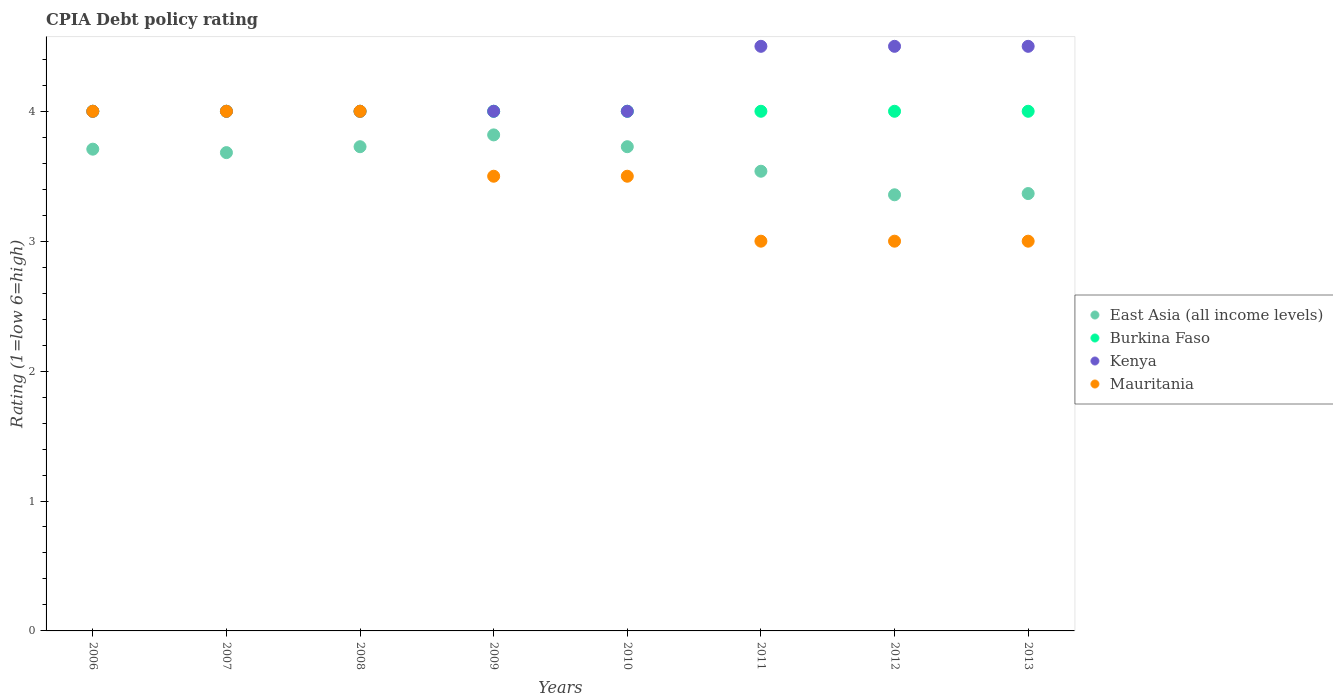How many different coloured dotlines are there?
Your answer should be compact. 4. What is the CPIA rating in East Asia (all income levels) in 2008?
Give a very brief answer. 3.73. Across all years, what is the maximum CPIA rating in East Asia (all income levels)?
Give a very brief answer. 3.82. Across all years, what is the minimum CPIA rating in East Asia (all income levels)?
Provide a succinct answer. 3.36. What is the total CPIA rating in Kenya in the graph?
Your response must be concise. 33.5. What is the difference between the CPIA rating in Burkina Faso in 2008 and the CPIA rating in Kenya in 2012?
Your answer should be very brief. -0.5. What is the average CPIA rating in Mauritania per year?
Your answer should be very brief. 3.5. In the year 2007, what is the difference between the CPIA rating in East Asia (all income levels) and CPIA rating in Kenya?
Your answer should be compact. -0.32. In how many years, is the CPIA rating in Mauritania greater than 3?
Ensure brevity in your answer.  5. What is the ratio of the CPIA rating in Kenya in 2009 to that in 2012?
Offer a terse response. 0.89. Is the CPIA rating in Burkina Faso in 2009 less than that in 2010?
Your answer should be very brief. No. Is the difference between the CPIA rating in East Asia (all income levels) in 2008 and 2009 greater than the difference between the CPIA rating in Kenya in 2008 and 2009?
Keep it short and to the point. No. What is the difference between the highest and the second highest CPIA rating in Burkina Faso?
Your response must be concise. 0. What is the difference between the highest and the lowest CPIA rating in Burkina Faso?
Provide a short and direct response. 0. Is the sum of the CPIA rating in Burkina Faso in 2008 and 2010 greater than the maximum CPIA rating in Mauritania across all years?
Provide a succinct answer. Yes. Is it the case that in every year, the sum of the CPIA rating in Mauritania and CPIA rating in Burkina Faso  is greater than the sum of CPIA rating in Kenya and CPIA rating in East Asia (all income levels)?
Offer a terse response. No. Is it the case that in every year, the sum of the CPIA rating in Burkina Faso and CPIA rating in Mauritania  is greater than the CPIA rating in Kenya?
Your response must be concise. Yes. Is the CPIA rating in Burkina Faso strictly greater than the CPIA rating in Kenya over the years?
Offer a very short reply. No. How many years are there in the graph?
Keep it short and to the point. 8. What is the difference between two consecutive major ticks on the Y-axis?
Make the answer very short. 1. Does the graph contain any zero values?
Keep it short and to the point. No. Does the graph contain grids?
Offer a terse response. No. What is the title of the graph?
Provide a succinct answer. CPIA Debt policy rating. Does "Guyana" appear as one of the legend labels in the graph?
Your response must be concise. No. What is the label or title of the Y-axis?
Offer a very short reply. Rating (1=low 6=high). What is the Rating (1=low 6=high) of East Asia (all income levels) in 2006?
Provide a short and direct response. 3.71. What is the Rating (1=low 6=high) in Mauritania in 2006?
Keep it short and to the point. 4. What is the Rating (1=low 6=high) in East Asia (all income levels) in 2007?
Keep it short and to the point. 3.68. What is the Rating (1=low 6=high) of Mauritania in 2007?
Provide a short and direct response. 4. What is the Rating (1=low 6=high) in East Asia (all income levels) in 2008?
Provide a short and direct response. 3.73. What is the Rating (1=low 6=high) of Burkina Faso in 2008?
Your answer should be compact. 4. What is the Rating (1=low 6=high) in East Asia (all income levels) in 2009?
Your answer should be very brief. 3.82. What is the Rating (1=low 6=high) of Burkina Faso in 2009?
Provide a short and direct response. 4. What is the Rating (1=low 6=high) of Kenya in 2009?
Keep it short and to the point. 4. What is the Rating (1=low 6=high) in East Asia (all income levels) in 2010?
Your answer should be compact. 3.73. What is the Rating (1=low 6=high) in Kenya in 2010?
Your answer should be compact. 4. What is the Rating (1=low 6=high) in East Asia (all income levels) in 2011?
Make the answer very short. 3.54. What is the Rating (1=low 6=high) in Burkina Faso in 2011?
Ensure brevity in your answer.  4. What is the Rating (1=low 6=high) of Kenya in 2011?
Your response must be concise. 4.5. What is the Rating (1=low 6=high) in Mauritania in 2011?
Keep it short and to the point. 3. What is the Rating (1=low 6=high) of East Asia (all income levels) in 2012?
Your answer should be compact. 3.36. What is the Rating (1=low 6=high) of Kenya in 2012?
Your answer should be very brief. 4.5. What is the Rating (1=low 6=high) in Mauritania in 2012?
Your answer should be very brief. 3. What is the Rating (1=low 6=high) of East Asia (all income levels) in 2013?
Offer a terse response. 3.37. What is the Rating (1=low 6=high) of Burkina Faso in 2013?
Your answer should be compact. 4. What is the Rating (1=low 6=high) in Mauritania in 2013?
Keep it short and to the point. 3. Across all years, what is the maximum Rating (1=low 6=high) of East Asia (all income levels)?
Your response must be concise. 3.82. Across all years, what is the maximum Rating (1=low 6=high) in Burkina Faso?
Your answer should be very brief. 4. Across all years, what is the maximum Rating (1=low 6=high) of Kenya?
Your answer should be very brief. 4.5. Across all years, what is the maximum Rating (1=low 6=high) in Mauritania?
Offer a very short reply. 4. Across all years, what is the minimum Rating (1=low 6=high) in East Asia (all income levels)?
Offer a terse response. 3.36. Across all years, what is the minimum Rating (1=low 6=high) in Burkina Faso?
Provide a short and direct response. 4. Across all years, what is the minimum Rating (1=low 6=high) of Mauritania?
Offer a very short reply. 3. What is the total Rating (1=low 6=high) in East Asia (all income levels) in the graph?
Provide a succinct answer. 28.93. What is the total Rating (1=low 6=high) in Burkina Faso in the graph?
Offer a very short reply. 32. What is the total Rating (1=low 6=high) of Kenya in the graph?
Your response must be concise. 33.5. What is the difference between the Rating (1=low 6=high) in East Asia (all income levels) in 2006 and that in 2007?
Offer a terse response. 0.03. What is the difference between the Rating (1=low 6=high) of Burkina Faso in 2006 and that in 2007?
Offer a terse response. 0. What is the difference between the Rating (1=low 6=high) of Kenya in 2006 and that in 2007?
Give a very brief answer. 0. What is the difference between the Rating (1=low 6=high) of East Asia (all income levels) in 2006 and that in 2008?
Offer a very short reply. -0.02. What is the difference between the Rating (1=low 6=high) in East Asia (all income levels) in 2006 and that in 2009?
Make the answer very short. -0.11. What is the difference between the Rating (1=low 6=high) of Burkina Faso in 2006 and that in 2009?
Your answer should be compact. 0. What is the difference between the Rating (1=low 6=high) in Kenya in 2006 and that in 2009?
Give a very brief answer. 0. What is the difference between the Rating (1=low 6=high) in Mauritania in 2006 and that in 2009?
Make the answer very short. 0.5. What is the difference between the Rating (1=low 6=high) in East Asia (all income levels) in 2006 and that in 2010?
Provide a succinct answer. -0.02. What is the difference between the Rating (1=low 6=high) in Burkina Faso in 2006 and that in 2010?
Your answer should be very brief. 0. What is the difference between the Rating (1=low 6=high) of Kenya in 2006 and that in 2010?
Provide a succinct answer. 0. What is the difference between the Rating (1=low 6=high) of Mauritania in 2006 and that in 2010?
Ensure brevity in your answer.  0.5. What is the difference between the Rating (1=low 6=high) of East Asia (all income levels) in 2006 and that in 2011?
Ensure brevity in your answer.  0.17. What is the difference between the Rating (1=low 6=high) in Mauritania in 2006 and that in 2011?
Keep it short and to the point. 1. What is the difference between the Rating (1=low 6=high) in East Asia (all income levels) in 2006 and that in 2012?
Provide a short and direct response. 0.35. What is the difference between the Rating (1=low 6=high) in Mauritania in 2006 and that in 2012?
Your answer should be very brief. 1. What is the difference between the Rating (1=low 6=high) of East Asia (all income levels) in 2006 and that in 2013?
Keep it short and to the point. 0.34. What is the difference between the Rating (1=low 6=high) in Burkina Faso in 2006 and that in 2013?
Make the answer very short. 0. What is the difference between the Rating (1=low 6=high) of East Asia (all income levels) in 2007 and that in 2008?
Make the answer very short. -0.05. What is the difference between the Rating (1=low 6=high) of Burkina Faso in 2007 and that in 2008?
Offer a very short reply. 0. What is the difference between the Rating (1=low 6=high) in East Asia (all income levels) in 2007 and that in 2009?
Your answer should be very brief. -0.14. What is the difference between the Rating (1=low 6=high) of East Asia (all income levels) in 2007 and that in 2010?
Provide a succinct answer. -0.05. What is the difference between the Rating (1=low 6=high) of Burkina Faso in 2007 and that in 2010?
Your answer should be compact. 0. What is the difference between the Rating (1=low 6=high) in East Asia (all income levels) in 2007 and that in 2011?
Keep it short and to the point. 0.14. What is the difference between the Rating (1=low 6=high) in Burkina Faso in 2007 and that in 2011?
Offer a terse response. 0. What is the difference between the Rating (1=low 6=high) in Mauritania in 2007 and that in 2011?
Provide a succinct answer. 1. What is the difference between the Rating (1=low 6=high) in East Asia (all income levels) in 2007 and that in 2012?
Give a very brief answer. 0.32. What is the difference between the Rating (1=low 6=high) of Burkina Faso in 2007 and that in 2012?
Your answer should be very brief. 0. What is the difference between the Rating (1=low 6=high) in Kenya in 2007 and that in 2012?
Provide a short and direct response. -0.5. What is the difference between the Rating (1=low 6=high) of Mauritania in 2007 and that in 2012?
Offer a very short reply. 1. What is the difference between the Rating (1=low 6=high) of East Asia (all income levels) in 2007 and that in 2013?
Offer a terse response. 0.32. What is the difference between the Rating (1=low 6=high) of Kenya in 2007 and that in 2013?
Provide a succinct answer. -0.5. What is the difference between the Rating (1=low 6=high) in Mauritania in 2007 and that in 2013?
Offer a very short reply. 1. What is the difference between the Rating (1=low 6=high) of East Asia (all income levels) in 2008 and that in 2009?
Your response must be concise. -0.09. What is the difference between the Rating (1=low 6=high) of Burkina Faso in 2008 and that in 2009?
Offer a terse response. 0. What is the difference between the Rating (1=low 6=high) in Mauritania in 2008 and that in 2009?
Offer a very short reply. 0.5. What is the difference between the Rating (1=low 6=high) in East Asia (all income levels) in 2008 and that in 2010?
Provide a short and direct response. 0. What is the difference between the Rating (1=low 6=high) of Burkina Faso in 2008 and that in 2010?
Give a very brief answer. 0. What is the difference between the Rating (1=low 6=high) in East Asia (all income levels) in 2008 and that in 2011?
Provide a short and direct response. 0.19. What is the difference between the Rating (1=low 6=high) in Kenya in 2008 and that in 2011?
Ensure brevity in your answer.  -0.5. What is the difference between the Rating (1=low 6=high) of Mauritania in 2008 and that in 2011?
Ensure brevity in your answer.  1. What is the difference between the Rating (1=low 6=high) in East Asia (all income levels) in 2008 and that in 2012?
Your answer should be compact. 0.37. What is the difference between the Rating (1=low 6=high) in Mauritania in 2008 and that in 2012?
Ensure brevity in your answer.  1. What is the difference between the Rating (1=low 6=high) in East Asia (all income levels) in 2008 and that in 2013?
Ensure brevity in your answer.  0.36. What is the difference between the Rating (1=low 6=high) of Burkina Faso in 2008 and that in 2013?
Your answer should be compact. 0. What is the difference between the Rating (1=low 6=high) of East Asia (all income levels) in 2009 and that in 2010?
Provide a succinct answer. 0.09. What is the difference between the Rating (1=low 6=high) in Burkina Faso in 2009 and that in 2010?
Keep it short and to the point. 0. What is the difference between the Rating (1=low 6=high) of Mauritania in 2009 and that in 2010?
Make the answer very short. 0. What is the difference between the Rating (1=low 6=high) of East Asia (all income levels) in 2009 and that in 2011?
Provide a short and direct response. 0.28. What is the difference between the Rating (1=low 6=high) of Kenya in 2009 and that in 2011?
Your answer should be compact. -0.5. What is the difference between the Rating (1=low 6=high) of Mauritania in 2009 and that in 2011?
Offer a very short reply. 0.5. What is the difference between the Rating (1=low 6=high) of East Asia (all income levels) in 2009 and that in 2012?
Provide a succinct answer. 0.46. What is the difference between the Rating (1=low 6=high) of Burkina Faso in 2009 and that in 2012?
Offer a terse response. 0. What is the difference between the Rating (1=low 6=high) of East Asia (all income levels) in 2009 and that in 2013?
Your response must be concise. 0.45. What is the difference between the Rating (1=low 6=high) of Burkina Faso in 2009 and that in 2013?
Your answer should be compact. 0. What is the difference between the Rating (1=low 6=high) of Kenya in 2009 and that in 2013?
Provide a short and direct response. -0.5. What is the difference between the Rating (1=low 6=high) in Mauritania in 2009 and that in 2013?
Offer a very short reply. 0.5. What is the difference between the Rating (1=low 6=high) in East Asia (all income levels) in 2010 and that in 2011?
Your answer should be very brief. 0.19. What is the difference between the Rating (1=low 6=high) of Burkina Faso in 2010 and that in 2011?
Your answer should be very brief. 0. What is the difference between the Rating (1=low 6=high) of East Asia (all income levels) in 2010 and that in 2012?
Keep it short and to the point. 0.37. What is the difference between the Rating (1=low 6=high) of Kenya in 2010 and that in 2012?
Offer a terse response. -0.5. What is the difference between the Rating (1=low 6=high) of East Asia (all income levels) in 2010 and that in 2013?
Ensure brevity in your answer.  0.36. What is the difference between the Rating (1=low 6=high) of Kenya in 2010 and that in 2013?
Offer a very short reply. -0.5. What is the difference between the Rating (1=low 6=high) of Mauritania in 2010 and that in 2013?
Keep it short and to the point. 0.5. What is the difference between the Rating (1=low 6=high) in East Asia (all income levels) in 2011 and that in 2012?
Offer a very short reply. 0.18. What is the difference between the Rating (1=low 6=high) in Burkina Faso in 2011 and that in 2012?
Your response must be concise. 0. What is the difference between the Rating (1=low 6=high) of East Asia (all income levels) in 2011 and that in 2013?
Provide a short and direct response. 0.17. What is the difference between the Rating (1=low 6=high) of Burkina Faso in 2011 and that in 2013?
Your answer should be very brief. 0. What is the difference between the Rating (1=low 6=high) in Kenya in 2011 and that in 2013?
Your answer should be compact. 0. What is the difference between the Rating (1=low 6=high) of East Asia (all income levels) in 2012 and that in 2013?
Offer a terse response. -0.01. What is the difference between the Rating (1=low 6=high) in Burkina Faso in 2012 and that in 2013?
Make the answer very short. 0. What is the difference between the Rating (1=low 6=high) of Mauritania in 2012 and that in 2013?
Your answer should be very brief. 0. What is the difference between the Rating (1=low 6=high) of East Asia (all income levels) in 2006 and the Rating (1=low 6=high) of Burkina Faso in 2007?
Offer a terse response. -0.29. What is the difference between the Rating (1=low 6=high) of East Asia (all income levels) in 2006 and the Rating (1=low 6=high) of Kenya in 2007?
Make the answer very short. -0.29. What is the difference between the Rating (1=low 6=high) of East Asia (all income levels) in 2006 and the Rating (1=low 6=high) of Mauritania in 2007?
Your answer should be very brief. -0.29. What is the difference between the Rating (1=low 6=high) in Burkina Faso in 2006 and the Rating (1=low 6=high) in Kenya in 2007?
Your answer should be very brief. 0. What is the difference between the Rating (1=low 6=high) in Burkina Faso in 2006 and the Rating (1=low 6=high) in Mauritania in 2007?
Ensure brevity in your answer.  0. What is the difference between the Rating (1=low 6=high) in East Asia (all income levels) in 2006 and the Rating (1=low 6=high) in Burkina Faso in 2008?
Your answer should be compact. -0.29. What is the difference between the Rating (1=low 6=high) of East Asia (all income levels) in 2006 and the Rating (1=low 6=high) of Kenya in 2008?
Provide a succinct answer. -0.29. What is the difference between the Rating (1=low 6=high) in East Asia (all income levels) in 2006 and the Rating (1=low 6=high) in Mauritania in 2008?
Provide a succinct answer. -0.29. What is the difference between the Rating (1=low 6=high) of Burkina Faso in 2006 and the Rating (1=low 6=high) of Kenya in 2008?
Ensure brevity in your answer.  0. What is the difference between the Rating (1=low 6=high) in Burkina Faso in 2006 and the Rating (1=low 6=high) in Mauritania in 2008?
Your answer should be very brief. 0. What is the difference between the Rating (1=low 6=high) in Kenya in 2006 and the Rating (1=low 6=high) in Mauritania in 2008?
Ensure brevity in your answer.  0. What is the difference between the Rating (1=low 6=high) of East Asia (all income levels) in 2006 and the Rating (1=low 6=high) of Burkina Faso in 2009?
Ensure brevity in your answer.  -0.29. What is the difference between the Rating (1=low 6=high) in East Asia (all income levels) in 2006 and the Rating (1=low 6=high) in Kenya in 2009?
Your response must be concise. -0.29. What is the difference between the Rating (1=low 6=high) in East Asia (all income levels) in 2006 and the Rating (1=low 6=high) in Mauritania in 2009?
Provide a succinct answer. 0.21. What is the difference between the Rating (1=low 6=high) of Burkina Faso in 2006 and the Rating (1=low 6=high) of Kenya in 2009?
Offer a very short reply. 0. What is the difference between the Rating (1=low 6=high) of East Asia (all income levels) in 2006 and the Rating (1=low 6=high) of Burkina Faso in 2010?
Keep it short and to the point. -0.29. What is the difference between the Rating (1=low 6=high) of East Asia (all income levels) in 2006 and the Rating (1=low 6=high) of Kenya in 2010?
Your answer should be very brief. -0.29. What is the difference between the Rating (1=low 6=high) of East Asia (all income levels) in 2006 and the Rating (1=low 6=high) of Mauritania in 2010?
Your response must be concise. 0.21. What is the difference between the Rating (1=low 6=high) of East Asia (all income levels) in 2006 and the Rating (1=low 6=high) of Burkina Faso in 2011?
Give a very brief answer. -0.29. What is the difference between the Rating (1=low 6=high) of East Asia (all income levels) in 2006 and the Rating (1=low 6=high) of Kenya in 2011?
Provide a succinct answer. -0.79. What is the difference between the Rating (1=low 6=high) in East Asia (all income levels) in 2006 and the Rating (1=low 6=high) in Mauritania in 2011?
Provide a succinct answer. 0.71. What is the difference between the Rating (1=low 6=high) of Burkina Faso in 2006 and the Rating (1=low 6=high) of Mauritania in 2011?
Keep it short and to the point. 1. What is the difference between the Rating (1=low 6=high) of East Asia (all income levels) in 2006 and the Rating (1=low 6=high) of Burkina Faso in 2012?
Provide a short and direct response. -0.29. What is the difference between the Rating (1=low 6=high) of East Asia (all income levels) in 2006 and the Rating (1=low 6=high) of Kenya in 2012?
Provide a short and direct response. -0.79. What is the difference between the Rating (1=low 6=high) in East Asia (all income levels) in 2006 and the Rating (1=low 6=high) in Mauritania in 2012?
Ensure brevity in your answer.  0.71. What is the difference between the Rating (1=low 6=high) of Burkina Faso in 2006 and the Rating (1=low 6=high) of Kenya in 2012?
Offer a terse response. -0.5. What is the difference between the Rating (1=low 6=high) in East Asia (all income levels) in 2006 and the Rating (1=low 6=high) in Burkina Faso in 2013?
Provide a short and direct response. -0.29. What is the difference between the Rating (1=low 6=high) in East Asia (all income levels) in 2006 and the Rating (1=low 6=high) in Kenya in 2013?
Provide a short and direct response. -0.79. What is the difference between the Rating (1=low 6=high) in East Asia (all income levels) in 2006 and the Rating (1=low 6=high) in Mauritania in 2013?
Keep it short and to the point. 0.71. What is the difference between the Rating (1=low 6=high) in Burkina Faso in 2006 and the Rating (1=low 6=high) in Kenya in 2013?
Offer a terse response. -0.5. What is the difference between the Rating (1=low 6=high) of Burkina Faso in 2006 and the Rating (1=low 6=high) of Mauritania in 2013?
Keep it short and to the point. 1. What is the difference between the Rating (1=low 6=high) in East Asia (all income levels) in 2007 and the Rating (1=low 6=high) in Burkina Faso in 2008?
Your answer should be very brief. -0.32. What is the difference between the Rating (1=low 6=high) of East Asia (all income levels) in 2007 and the Rating (1=low 6=high) of Kenya in 2008?
Your answer should be compact. -0.32. What is the difference between the Rating (1=low 6=high) of East Asia (all income levels) in 2007 and the Rating (1=low 6=high) of Mauritania in 2008?
Make the answer very short. -0.32. What is the difference between the Rating (1=low 6=high) of Burkina Faso in 2007 and the Rating (1=low 6=high) of Mauritania in 2008?
Keep it short and to the point. 0. What is the difference between the Rating (1=low 6=high) of Kenya in 2007 and the Rating (1=low 6=high) of Mauritania in 2008?
Keep it short and to the point. 0. What is the difference between the Rating (1=low 6=high) of East Asia (all income levels) in 2007 and the Rating (1=low 6=high) of Burkina Faso in 2009?
Keep it short and to the point. -0.32. What is the difference between the Rating (1=low 6=high) of East Asia (all income levels) in 2007 and the Rating (1=low 6=high) of Kenya in 2009?
Make the answer very short. -0.32. What is the difference between the Rating (1=low 6=high) in East Asia (all income levels) in 2007 and the Rating (1=low 6=high) in Mauritania in 2009?
Provide a short and direct response. 0.18. What is the difference between the Rating (1=low 6=high) in Burkina Faso in 2007 and the Rating (1=low 6=high) in Kenya in 2009?
Ensure brevity in your answer.  0. What is the difference between the Rating (1=low 6=high) of Burkina Faso in 2007 and the Rating (1=low 6=high) of Mauritania in 2009?
Provide a short and direct response. 0.5. What is the difference between the Rating (1=low 6=high) of Kenya in 2007 and the Rating (1=low 6=high) of Mauritania in 2009?
Keep it short and to the point. 0.5. What is the difference between the Rating (1=low 6=high) in East Asia (all income levels) in 2007 and the Rating (1=low 6=high) in Burkina Faso in 2010?
Provide a short and direct response. -0.32. What is the difference between the Rating (1=low 6=high) of East Asia (all income levels) in 2007 and the Rating (1=low 6=high) of Kenya in 2010?
Keep it short and to the point. -0.32. What is the difference between the Rating (1=low 6=high) of East Asia (all income levels) in 2007 and the Rating (1=low 6=high) of Mauritania in 2010?
Ensure brevity in your answer.  0.18. What is the difference between the Rating (1=low 6=high) in Burkina Faso in 2007 and the Rating (1=low 6=high) in Kenya in 2010?
Give a very brief answer. 0. What is the difference between the Rating (1=low 6=high) in Burkina Faso in 2007 and the Rating (1=low 6=high) in Mauritania in 2010?
Your response must be concise. 0.5. What is the difference between the Rating (1=low 6=high) in Kenya in 2007 and the Rating (1=low 6=high) in Mauritania in 2010?
Offer a very short reply. 0.5. What is the difference between the Rating (1=low 6=high) in East Asia (all income levels) in 2007 and the Rating (1=low 6=high) in Burkina Faso in 2011?
Ensure brevity in your answer.  -0.32. What is the difference between the Rating (1=low 6=high) of East Asia (all income levels) in 2007 and the Rating (1=low 6=high) of Kenya in 2011?
Keep it short and to the point. -0.82. What is the difference between the Rating (1=low 6=high) of East Asia (all income levels) in 2007 and the Rating (1=low 6=high) of Mauritania in 2011?
Your answer should be very brief. 0.68. What is the difference between the Rating (1=low 6=high) in Burkina Faso in 2007 and the Rating (1=low 6=high) in Kenya in 2011?
Provide a short and direct response. -0.5. What is the difference between the Rating (1=low 6=high) in Burkina Faso in 2007 and the Rating (1=low 6=high) in Mauritania in 2011?
Provide a succinct answer. 1. What is the difference between the Rating (1=low 6=high) of Kenya in 2007 and the Rating (1=low 6=high) of Mauritania in 2011?
Your response must be concise. 1. What is the difference between the Rating (1=low 6=high) in East Asia (all income levels) in 2007 and the Rating (1=low 6=high) in Burkina Faso in 2012?
Provide a succinct answer. -0.32. What is the difference between the Rating (1=low 6=high) of East Asia (all income levels) in 2007 and the Rating (1=low 6=high) of Kenya in 2012?
Ensure brevity in your answer.  -0.82. What is the difference between the Rating (1=low 6=high) in East Asia (all income levels) in 2007 and the Rating (1=low 6=high) in Mauritania in 2012?
Your response must be concise. 0.68. What is the difference between the Rating (1=low 6=high) of Burkina Faso in 2007 and the Rating (1=low 6=high) of Mauritania in 2012?
Provide a succinct answer. 1. What is the difference between the Rating (1=low 6=high) in Kenya in 2007 and the Rating (1=low 6=high) in Mauritania in 2012?
Your answer should be very brief. 1. What is the difference between the Rating (1=low 6=high) in East Asia (all income levels) in 2007 and the Rating (1=low 6=high) in Burkina Faso in 2013?
Provide a succinct answer. -0.32. What is the difference between the Rating (1=low 6=high) in East Asia (all income levels) in 2007 and the Rating (1=low 6=high) in Kenya in 2013?
Make the answer very short. -0.82. What is the difference between the Rating (1=low 6=high) of East Asia (all income levels) in 2007 and the Rating (1=low 6=high) of Mauritania in 2013?
Give a very brief answer. 0.68. What is the difference between the Rating (1=low 6=high) in Burkina Faso in 2007 and the Rating (1=low 6=high) in Kenya in 2013?
Keep it short and to the point. -0.5. What is the difference between the Rating (1=low 6=high) in Burkina Faso in 2007 and the Rating (1=low 6=high) in Mauritania in 2013?
Your answer should be compact. 1. What is the difference between the Rating (1=low 6=high) in Kenya in 2007 and the Rating (1=low 6=high) in Mauritania in 2013?
Provide a succinct answer. 1. What is the difference between the Rating (1=low 6=high) in East Asia (all income levels) in 2008 and the Rating (1=low 6=high) in Burkina Faso in 2009?
Give a very brief answer. -0.27. What is the difference between the Rating (1=low 6=high) of East Asia (all income levels) in 2008 and the Rating (1=low 6=high) of Kenya in 2009?
Keep it short and to the point. -0.27. What is the difference between the Rating (1=low 6=high) in East Asia (all income levels) in 2008 and the Rating (1=low 6=high) in Mauritania in 2009?
Provide a succinct answer. 0.23. What is the difference between the Rating (1=low 6=high) of Burkina Faso in 2008 and the Rating (1=low 6=high) of Kenya in 2009?
Ensure brevity in your answer.  0. What is the difference between the Rating (1=low 6=high) in Kenya in 2008 and the Rating (1=low 6=high) in Mauritania in 2009?
Your response must be concise. 0.5. What is the difference between the Rating (1=low 6=high) of East Asia (all income levels) in 2008 and the Rating (1=low 6=high) of Burkina Faso in 2010?
Keep it short and to the point. -0.27. What is the difference between the Rating (1=low 6=high) in East Asia (all income levels) in 2008 and the Rating (1=low 6=high) in Kenya in 2010?
Your answer should be very brief. -0.27. What is the difference between the Rating (1=low 6=high) in East Asia (all income levels) in 2008 and the Rating (1=low 6=high) in Mauritania in 2010?
Provide a succinct answer. 0.23. What is the difference between the Rating (1=low 6=high) of Burkina Faso in 2008 and the Rating (1=low 6=high) of Mauritania in 2010?
Give a very brief answer. 0.5. What is the difference between the Rating (1=low 6=high) of East Asia (all income levels) in 2008 and the Rating (1=low 6=high) of Burkina Faso in 2011?
Offer a very short reply. -0.27. What is the difference between the Rating (1=low 6=high) of East Asia (all income levels) in 2008 and the Rating (1=low 6=high) of Kenya in 2011?
Your answer should be very brief. -0.77. What is the difference between the Rating (1=low 6=high) of East Asia (all income levels) in 2008 and the Rating (1=low 6=high) of Mauritania in 2011?
Your answer should be very brief. 0.73. What is the difference between the Rating (1=low 6=high) in Burkina Faso in 2008 and the Rating (1=low 6=high) in Kenya in 2011?
Your response must be concise. -0.5. What is the difference between the Rating (1=low 6=high) of East Asia (all income levels) in 2008 and the Rating (1=low 6=high) of Burkina Faso in 2012?
Provide a succinct answer. -0.27. What is the difference between the Rating (1=low 6=high) in East Asia (all income levels) in 2008 and the Rating (1=low 6=high) in Kenya in 2012?
Offer a very short reply. -0.77. What is the difference between the Rating (1=low 6=high) of East Asia (all income levels) in 2008 and the Rating (1=low 6=high) of Mauritania in 2012?
Keep it short and to the point. 0.73. What is the difference between the Rating (1=low 6=high) of Burkina Faso in 2008 and the Rating (1=low 6=high) of Kenya in 2012?
Offer a very short reply. -0.5. What is the difference between the Rating (1=low 6=high) of Burkina Faso in 2008 and the Rating (1=low 6=high) of Mauritania in 2012?
Provide a succinct answer. 1. What is the difference between the Rating (1=low 6=high) of East Asia (all income levels) in 2008 and the Rating (1=low 6=high) of Burkina Faso in 2013?
Ensure brevity in your answer.  -0.27. What is the difference between the Rating (1=low 6=high) in East Asia (all income levels) in 2008 and the Rating (1=low 6=high) in Kenya in 2013?
Your answer should be very brief. -0.77. What is the difference between the Rating (1=low 6=high) in East Asia (all income levels) in 2008 and the Rating (1=low 6=high) in Mauritania in 2013?
Offer a very short reply. 0.73. What is the difference between the Rating (1=low 6=high) in Burkina Faso in 2008 and the Rating (1=low 6=high) in Mauritania in 2013?
Offer a very short reply. 1. What is the difference between the Rating (1=low 6=high) in East Asia (all income levels) in 2009 and the Rating (1=low 6=high) in Burkina Faso in 2010?
Make the answer very short. -0.18. What is the difference between the Rating (1=low 6=high) of East Asia (all income levels) in 2009 and the Rating (1=low 6=high) of Kenya in 2010?
Your answer should be very brief. -0.18. What is the difference between the Rating (1=low 6=high) in East Asia (all income levels) in 2009 and the Rating (1=low 6=high) in Mauritania in 2010?
Offer a very short reply. 0.32. What is the difference between the Rating (1=low 6=high) in Burkina Faso in 2009 and the Rating (1=low 6=high) in Kenya in 2010?
Keep it short and to the point. 0. What is the difference between the Rating (1=low 6=high) of Burkina Faso in 2009 and the Rating (1=low 6=high) of Mauritania in 2010?
Provide a short and direct response. 0.5. What is the difference between the Rating (1=low 6=high) in Kenya in 2009 and the Rating (1=low 6=high) in Mauritania in 2010?
Provide a short and direct response. 0.5. What is the difference between the Rating (1=low 6=high) of East Asia (all income levels) in 2009 and the Rating (1=low 6=high) of Burkina Faso in 2011?
Make the answer very short. -0.18. What is the difference between the Rating (1=low 6=high) of East Asia (all income levels) in 2009 and the Rating (1=low 6=high) of Kenya in 2011?
Your answer should be very brief. -0.68. What is the difference between the Rating (1=low 6=high) in East Asia (all income levels) in 2009 and the Rating (1=low 6=high) in Mauritania in 2011?
Your response must be concise. 0.82. What is the difference between the Rating (1=low 6=high) of Burkina Faso in 2009 and the Rating (1=low 6=high) of Kenya in 2011?
Ensure brevity in your answer.  -0.5. What is the difference between the Rating (1=low 6=high) in Kenya in 2009 and the Rating (1=low 6=high) in Mauritania in 2011?
Your answer should be very brief. 1. What is the difference between the Rating (1=low 6=high) of East Asia (all income levels) in 2009 and the Rating (1=low 6=high) of Burkina Faso in 2012?
Give a very brief answer. -0.18. What is the difference between the Rating (1=low 6=high) of East Asia (all income levels) in 2009 and the Rating (1=low 6=high) of Kenya in 2012?
Provide a short and direct response. -0.68. What is the difference between the Rating (1=low 6=high) of East Asia (all income levels) in 2009 and the Rating (1=low 6=high) of Mauritania in 2012?
Provide a succinct answer. 0.82. What is the difference between the Rating (1=low 6=high) of East Asia (all income levels) in 2009 and the Rating (1=low 6=high) of Burkina Faso in 2013?
Your answer should be compact. -0.18. What is the difference between the Rating (1=low 6=high) of East Asia (all income levels) in 2009 and the Rating (1=low 6=high) of Kenya in 2013?
Provide a short and direct response. -0.68. What is the difference between the Rating (1=low 6=high) of East Asia (all income levels) in 2009 and the Rating (1=low 6=high) of Mauritania in 2013?
Your answer should be very brief. 0.82. What is the difference between the Rating (1=low 6=high) in Burkina Faso in 2009 and the Rating (1=low 6=high) in Mauritania in 2013?
Provide a short and direct response. 1. What is the difference between the Rating (1=low 6=high) in East Asia (all income levels) in 2010 and the Rating (1=low 6=high) in Burkina Faso in 2011?
Provide a succinct answer. -0.27. What is the difference between the Rating (1=low 6=high) of East Asia (all income levels) in 2010 and the Rating (1=low 6=high) of Kenya in 2011?
Provide a succinct answer. -0.77. What is the difference between the Rating (1=low 6=high) in East Asia (all income levels) in 2010 and the Rating (1=low 6=high) in Mauritania in 2011?
Your response must be concise. 0.73. What is the difference between the Rating (1=low 6=high) of Burkina Faso in 2010 and the Rating (1=low 6=high) of Mauritania in 2011?
Make the answer very short. 1. What is the difference between the Rating (1=low 6=high) in Kenya in 2010 and the Rating (1=low 6=high) in Mauritania in 2011?
Ensure brevity in your answer.  1. What is the difference between the Rating (1=low 6=high) in East Asia (all income levels) in 2010 and the Rating (1=low 6=high) in Burkina Faso in 2012?
Offer a terse response. -0.27. What is the difference between the Rating (1=low 6=high) of East Asia (all income levels) in 2010 and the Rating (1=low 6=high) of Kenya in 2012?
Your answer should be compact. -0.77. What is the difference between the Rating (1=low 6=high) in East Asia (all income levels) in 2010 and the Rating (1=low 6=high) in Mauritania in 2012?
Your answer should be compact. 0.73. What is the difference between the Rating (1=low 6=high) of Burkina Faso in 2010 and the Rating (1=low 6=high) of Mauritania in 2012?
Make the answer very short. 1. What is the difference between the Rating (1=low 6=high) of East Asia (all income levels) in 2010 and the Rating (1=low 6=high) of Burkina Faso in 2013?
Provide a short and direct response. -0.27. What is the difference between the Rating (1=low 6=high) in East Asia (all income levels) in 2010 and the Rating (1=low 6=high) in Kenya in 2013?
Make the answer very short. -0.77. What is the difference between the Rating (1=low 6=high) in East Asia (all income levels) in 2010 and the Rating (1=low 6=high) in Mauritania in 2013?
Give a very brief answer. 0.73. What is the difference between the Rating (1=low 6=high) of Burkina Faso in 2010 and the Rating (1=low 6=high) of Mauritania in 2013?
Ensure brevity in your answer.  1. What is the difference between the Rating (1=low 6=high) of East Asia (all income levels) in 2011 and the Rating (1=low 6=high) of Burkina Faso in 2012?
Provide a short and direct response. -0.46. What is the difference between the Rating (1=low 6=high) of East Asia (all income levels) in 2011 and the Rating (1=low 6=high) of Kenya in 2012?
Ensure brevity in your answer.  -0.96. What is the difference between the Rating (1=low 6=high) of East Asia (all income levels) in 2011 and the Rating (1=low 6=high) of Mauritania in 2012?
Offer a terse response. 0.54. What is the difference between the Rating (1=low 6=high) in Burkina Faso in 2011 and the Rating (1=low 6=high) in Kenya in 2012?
Offer a very short reply. -0.5. What is the difference between the Rating (1=low 6=high) of Burkina Faso in 2011 and the Rating (1=low 6=high) of Mauritania in 2012?
Give a very brief answer. 1. What is the difference between the Rating (1=low 6=high) of East Asia (all income levels) in 2011 and the Rating (1=low 6=high) of Burkina Faso in 2013?
Make the answer very short. -0.46. What is the difference between the Rating (1=low 6=high) of East Asia (all income levels) in 2011 and the Rating (1=low 6=high) of Kenya in 2013?
Provide a succinct answer. -0.96. What is the difference between the Rating (1=low 6=high) in East Asia (all income levels) in 2011 and the Rating (1=low 6=high) in Mauritania in 2013?
Provide a succinct answer. 0.54. What is the difference between the Rating (1=low 6=high) of Burkina Faso in 2011 and the Rating (1=low 6=high) of Kenya in 2013?
Your answer should be compact. -0.5. What is the difference between the Rating (1=low 6=high) of Burkina Faso in 2011 and the Rating (1=low 6=high) of Mauritania in 2013?
Give a very brief answer. 1. What is the difference between the Rating (1=low 6=high) in Kenya in 2011 and the Rating (1=low 6=high) in Mauritania in 2013?
Ensure brevity in your answer.  1.5. What is the difference between the Rating (1=low 6=high) in East Asia (all income levels) in 2012 and the Rating (1=low 6=high) in Burkina Faso in 2013?
Provide a succinct answer. -0.64. What is the difference between the Rating (1=low 6=high) of East Asia (all income levels) in 2012 and the Rating (1=low 6=high) of Kenya in 2013?
Make the answer very short. -1.14. What is the difference between the Rating (1=low 6=high) of East Asia (all income levels) in 2012 and the Rating (1=low 6=high) of Mauritania in 2013?
Make the answer very short. 0.36. What is the average Rating (1=low 6=high) in East Asia (all income levels) per year?
Offer a very short reply. 3.62. What is the average Rating (1=low 6=high) in Kenya per year?
Provide a succinct answer. 4.19. In the year 2006, what is the difference between the Rating (1=low 6=high) of East Asia (all income levels) and Rating (1=low 6=high) of Burkina Faso?
Ensure brevity in your answer.  -0.29. In the year 2006, what is the difference between the Rating (1=low 6=high) in East Asia (all income levels) and Rating (1=low 6=high) in Kenya?
Ensure brevity in your answer.  -0.29. In the year 2006, what is the difference between the Rating (1=low 6=high) of East Asia (all income levels) and Rating (1=low 6=high) of Mauritania?
Your answer should be compact. -0.29. In the year 2007, what is the difference between the Rating (1=low 6=high) in East Asia (all income levels) and Rating (1=low 6=high) in Burkina Faso?
Your answer should be very brief. -0.32. In the year 2007, what is the difference between the Rating (1=low 6=high) of East Asia (all income levels) and Rating (1=low 6=high) of Kenya?
Your response must be concise. -0.32. In the year 2007, what is the difference between the Rating (1=low 6=high) in East Asia (all income levels) and Rating (1=low 6=high) in Mauritania?
Give a very brief answer. -0.32. In the year 2007, what is the difference between the Rating (1=low 6=high) of Burkina Faso and Rating (1=low 6=high) of Kenya?
Provide a succinct answer. 0. In the year 2007, what is the difference between the Rating (1=low 6=high) in Burkina Faso and Rating (1=low 6=high) in Mauritania?
Make the answer very short. 0. In the year 2007, what is the difference between the Rating (1=low 6=high) in Kenya and Rating (1=low 6=high) in Mauritania?
Keep it short and to the point. 0. In the year 2008, what is the difference between the Rating (1=low 6=high) in East Asia (all income levels) and Rating (1=low 6=high) in Burkina Faso?
Your answer should be very brief. -0.27. In the year 2008, what is the difference between the Rating (1=low 6=high) of East Asia (all income levels) and Rating (1=low 6=high) of Kenya?
Your response must be concise. -0.27. In the year 2008, what is the difference between the Rating (1=low 6=high) in East Asia (all income levels) and Rating (1=low 6=high) in Mauritania?
Your answer should be compact. -0.27. In the year 2008, what is the difference between the Rating (1=low 6=high) of Burkina Faso and Rating (1=low 6=high) of Kenya?
Keep it short and to the point. 0. In the year 2008, what is the difference between the Rating (1=low 6=high) of Kenya and Rating (1=low 6=high) of Mauritania?
Your answer should be very brief. 0. In the year 2009, what is the difference between the Rating (1=low 6=high) of East Asia (all income levels) and Rating (1=low 6=high) of Burkina Faso?
Offer a very short reply. -0.18. In the year 2009, what is the difference between the Rating (1=low 6=high) in East Asia (all income levels) and Rating (1=low 6=high) in Kenya?
Offer a terse response. -0.18. In the year 2009, what is the difference between the Rating (1=low 6=high) of East Asia (all income levels) and Rating (1=low 6=high) of Mauritania?
Provide a succinct answer. 0.32. In the year 2009, what is the difference between the Rating (1=low 6=high) of Kenya and Rating (1=low 6=high) of Mauritania?
Give a very brief answer. 0.5. In the year 2010, what is the difference between the Rating (1=low 6=high) in East Asia (all income levels) and Rating (1=low 6=high) in Burkina Faso?
Give a very brief answer. -0.27. In the year 2010, what is the difference between the Rating (1=low 6=high) of East Asia (all income levels) and Rating (1=low 6=high) of Kenya?
Make the answer very short. -0.27. In the year 2010, what is the difference between the Rating (1=low 6=high) of East Asia (all income levels) and Rating (1=low 6=high) of Mauritania?
Make the answer very short. 0.23. In the year 2010, what is the difference between the Rating (1=low 6=high) in Burkina Faso and Rating (1=low 6=high) in Kenya?
Keep it short and to the point. 0. In the year 2010, what is the difference between the Rating (1=low 6=high) in Burkina Faso and Rating (1=low 6=high) in Mauritania?
Your answer should be very brief. 0.5. In the year 2011, what is the difference between the Rating (1=low 6=high) of East Asia (all income levels) and Rating (1=low 6=high) of Burkina Faso?
Provide a succinct answer. -0.46. In the year 2011, what is the difference between the Rating (1=low 6=high) of East Asia (all income levels) and Rating (1=low 6=high) of Kenya?
Your answer should be compact. -0.96. In the year 2011, what is the difference between the Rating (1=low 6=high) of East Asia (all income levels) and Rating (1=low 6=high) of Mauritania?
Offer a very short reply. 0.54. In the year 2011, what is the difference between the Rating (1=low 6=high) in Burkina Faso and Rating (1=low 6=high) in Kenya?
Offer a very short reply. -0.5. In the year 2011, what is the difference between the Rating (1=low 6=high) in Burkina Faso and Rating (1=low 6=high) in Mauritania?
Make the answer very short. 1. In the year 2012, what is the difference between the Rating (1=low 6=high) of East Asia (all income levels) and Rating (1=low 6=high) of Burkina Faso?
Keep it short and to the point. -0.64. In the year 2012, what is the difference between the Rating (1=low 6=high) in East Asia (all income levels) and Rating (1=low 6=high) in Kenya?
Offer a very short reply. -1.14. In the year 2012, what is the difference between the Rating (1=low 6=high) in East Asia (all income levels) and Rating (1=low 6=high) in Mauritania?
Keep it short and to the point. 0.36. In the year 2012, what is the difference between the Rating (1=low 6=high) of Burkina Faso and Rating (1=low 6=high) of Mauritania?
Ensure brevity in your answer.  1. In the year 2012, what is the difference between the Rating (1=low 6=high) in Kenya and Rating (1=low 6=high) in Mauritania?
Your answer should be very brief. 1.5. In the year 2013, what is the difference between the Rating (1=low 6=high) in East Asia (all income levels) and Rating (1=low 6=high) in Burkina Faso?
Make the answer very short. -0.63. In the year 2013, what is the difference between the Rating (1=low 6=high) in East Asia (all income levels) and Rating (1=low 6=high) in Kenya?
Offer a very short reply. -1.13. In the year 2013, what is the difference between the Rating (1=low 6=high) in East Asia (all income levels) and Rating (1=low 6=high) in Mauritania?
Provide a short and direct response. 0.37. In the year 2013, what is the difference between the Rating (1=low 6=high) of Burkina Faso and Rating (1=low 6=high) of Kenya?
Provide a succinct answer. -0.5. In the year 2013, what is the difference between the Rating (1=low 6=high) in Burkina Faso and Rating (1=low 6=high) in Mauritania?
Your answer should be very brief. 1. In the year 2013, what is the difference between the Rating (1=low 6=high) of Kenya and Rating (1=low 6=high) of Mauritania?
Your response must be concise. 1.5. What is the ratio of the Rating (1=low 6=high) of Kenya in 2006 to that in 2007?
Provide a short and direct response. 1. What is the ratio of the Rating (1=low 6=high) of Burkina Faso in 2006 to that in 2008?
Provide a succinct answer. 1. What is the ratio of the Rating (1=low 6=high) in Kenya in 2006 to that in 2008?
Your answer should be very brief. 1. What is the ratio of the Rating (1=low 6=high) in Mauritania in 2006 to that in 2008?
Your answer should be very brief. 1. What is the ratio of the Rating (1=low 6=high) in East Asia (all income levels) in 2006 to that in 2009?
Ensure brevity in your answer.  0.97. What is the ratio of the Rating (1=low 6=high) of Mauritania in 2006 to that in 2009?
Keep it short and to the point. 1.14. What is the ratio of the Rating (1=low 6=high) in East Asia (all income levels) in 2006 to that in 2010?
Your answer should be very brief. 0.99. What is the ratio of the Rating (1=low 6=high) of Burkina Faso in 2006 to that in 2010?
Your answer should be very brief. 1. What is the ratio of the Rating (1=low 6=high) of Kenya in 2006 to that in 2010?
Offer a very short reply. 1. What is the ratio of the Rating (1=low 6=high) of Mauritania in 2006 to that in 2010?
Provide a short and direct response. 1.14. What is the ratio of the Rating (1=low 6=high) in East Asia (all income levels) in 2006 to that in 2011?
Your answer should be very brief. 1.05. What is the ratio of the Rating (1=low 6=high) in Kenya in 2006 to that in 2011?
Keep it short and to the point. 0.89. What is the ratio of the Rating (1=low 6=high) in East Asia (all income levels) in 2006 to that in 2012?
Give a very brief answer. 1.1. What is the ratio of the Rating (1=low 6=high) of East Asia (all income levels) in 2006 to that in 2013?
Offer a terse response. 1.1. What is the ratio of the Rating (1=low 6=high) of East Asia (all income levels) in 2007 to that in 2009?
Ensure brevity in your answer.  0.96. What is the ratio of the Rating (1=low 6=high) of Burkina Faso in 2007 to that in 2010?
Keep it short and to the point. 1. What is the ratio of the Rating (1=low 6=high) in Mauritania in 2007 to that in 2010?
Keep it short and to the point. 1.14. What is the ratio of the Rating (1=low 6=high) in East Asia (all income levels) in 2007 to that in 2011?
Ensure brevity in your answer.  1.04. What is the ratio of the Rating (1=low 6=high) in Burkina Faso in 2007 to that in 2011?
Offer a terse response. 1. What is the ratio of the Rating (1=low 6=high) of East Asia (all income levels) in 2007 to that in 2012?
Your answer should be very brief. 1.1. What is the ratio of the Rating (1=low 6=high) in Kenya in 2007 to that in 2012?
Keep it short and to the point. 0.89. What is the ratio of the Rating (1=low 6=high) in East Asia (all income levels) in 2007 to that in 2013?
Ensure brevity in your answer.  1.09. What is the ratio of the Rating (1=low 6=high) of Burkina Faso in 2007 to that in 2013?
Provide a short and direct response. 1. What is the ratio of the Rating (1=low 6=high) of Kenya in 2007 to that in 2013?
Offer a very short reply. 0.89. What is the ratio of the Rating (1=low 6=high) in East Asia (all income levels) in 2008 to that in 2009?
Offer a very short reply. 0.98. What is the ratio of the Rating (1=low 6=high) of Kenya in 2008 to that in 2009?
Give a very brief answer. 1. What is the ratio of the Rating (1=low 6=high) of Mauritania in 2008 to that in 2009?
Keep it short and to the point. 1.14. What is the ratio of the Rating (1=low 6=high) in Kenya in 2008 to that in 2010?
Offer a very short reply. 1. What is the ratio of the Rating (1=low 6=high) of Mauritania in 2008 to that in 2010?
Ensure brevity in your answer.  1.14. What is the ratio of the Rating (1=low 6=high) in East Asia (all income levels) in 2008 to that in 2011?
Your answer should be very brief. 1.05. What is the ratio of the Rating (1=low 6=high) in Kenya in 2008 to that in 2011?
Offer a terse response. 0.89. What is the ratio of the Rating (1=low 6=high) of Mauritania in 2008 to that in 2011?
Your answer should be compact. 1.33. What is the ratio of the Rating (1=low 6=high) of East Asia (all income levels) in 2008 to that in 2012?
Your answer should be compact. 1.11. What is the ratio of the Rating (1=low 6=high) of Burkina Faso in 2008 to that in 2012?
Provide a short and direct response. 1. What is the ratio of the Rating (1=low 6=high) in Kenya in 2008 to that in 2012?
Offer a terse response. 0.89. What is the ratio of the Rating (1=low 6=high) in Mauritania in 2008 to that in 2012?
Your answer should be compact. 1.33. What is the ratio of the Rating (1=low 6=high) in East Asia (all income levels) in 2008 to that in 2013?
Give a very brief answer. 1.11. What is the ratio of the Rating (1=low 6=high) of Kenya in 2008 to that in 2013?
Offer a very short reply. 0.89. What is the ratio of the Rating (1=low 6=high) in Mauritania in 2008 to that in 2013?
Give a very brief answer. 1.33. What is the ratio of the Rating (1=low 6=high) of East Asia (all income levels) in 2009 to that in 2010?
Offer a terse response. 1.02. What is the ratio of the Rating (1=low 6=high) in Burkina Faso in 2009 to that in 2010?
Your answer should be compact. 1. What is the ratio of the Rating (1=low 6=high) in Kenya in 2009 to that in 2010?
Offer a very short reply. 1. What is the ratio of the Rating (1=low 6=high) of Mauritania in 2009 to that in 2010?
Give a very brief answer. 1. What is the ratio of the Rating (1=low 6=high) of East Asia (all income levels) in 2009 to that in 2011?
Your response must be concise. 1.08. What is the ratio of the Rating (1=low 6=high) in East Asia (all income levels) in 2009 to that in 2012?
Make the answer very short. 1.14. What is the ratio of the Rating (1=low 6=high) in Kenya in 2009 to that in 2012?
Ensure brevity in your answer.  0.89. What is the ratio of the Rating (1=low 6=high) in East Asia (all income levels) in 2009 to that in 2013?
Your answer should be very brief. 1.13. What is the ratio of the Rating (1=low 6=high) in Kenya in 2009 to that in 2013?
Offer a very short reply. 0.89. What is the ratio of the Rating (1=low 6=high) of Mauritania in 2009 to that in 2013?
Provide a short and direct response. 1.17. What is the ratio of the Rating (1=low 6=high) of East Asia (all income levels) in 2010 to that in 2011?
Your answer should be very brief. 1.05. What is the ratio of the Rating (1=low 6=high) in Burkina Faso in 2010 to that in 2011?
Make the answer very short. 1. What is the ratio of the Rating (1=low 6=high) of Kenya in 2010 to that in 2011?
Keep it short and to the point. 0.89. What is the ratio of the Rating (1=low 6=high) in Mauritania in 2010 to that in 2011?
Ensure brevity in your answer.  1.17. What is the ratio of the Rating (1=low 6=high) of East Asia (all income levels) in 2010 to that in 2012?
Give a very brief answer. 1.11. What is the ratio of the Rating (1=low 6=high) of East Asia (all income levels) in 2010 to that in 2013?
Keep it short and to the point. 1.11. What is the ratio of the Rating (1=low 6=high) of Burkina Faso in 2010 to that in 2013?
Make the answer very short. 1. What is the ratio of the Rating (1=low 6=high) in Kenya in 2010 to that in 2013?
Offer a very short reply. 0.89. What is the ratio of the Rating (1=low 6=high) of East Asia (all income levels) in 2011 to that in 2012?
Keep it short and to the point. 1.05. What is the ratio of the Rating (1=low 6=high) in Kenya in 2011 to that in 2012?
Provide a short and direct response. 1. What is the ratio of the Rating (1=low 6=high) in Mauritania in 2011 to that in 2012?
Your answer should be very brief. 1. What is the ratio of the Rating (1=low 6=high) of East Asia (all income levels) in 2011 to that in 2013?
Your answer should be compact. 1.05. What is the ratio of the Rating (1=low 6=high) of Kenya in 2011 to that in 2013?
Provide a succinct answer. 1. What is the ratio of the Rating (1=low 6=high) of East Asia (all income levels) in 2012 to that in 2013?
Your response must be concise. 1. What is the ratio of the Rating (1=low 6=high) of Burkina Faso in 2012 to that in 2013?
Ensure brevity in your answer.  1. What is the ratio of the Rating (1=low 6=high) of Kenya in 2012 to that in 2013?
Give a very brief answer. 1. What is the difference between the highest and the second highest Rating (1=low 6=high) in East Asia (all income levels)?
Ensure brevity in your answer.  0.09. What is the difference between the highest and the second highest Rating (1=low 6=high) in Burkina Faso?
Make the answer very short. 0. What is the difference between the highest and the second highest Rating (1=low 6=high) in Kenya?
Keep it short and to the point. 0. What is the difference between the highest and the lowest Rating (1=low 6=high) of East Asia (all income levels)?
Make the answer very short. 0.46. What is the difference between the highest and the lowest Rating (1=low 6=high) of Mauritania?
Ensure brevity in your answer.  1. 